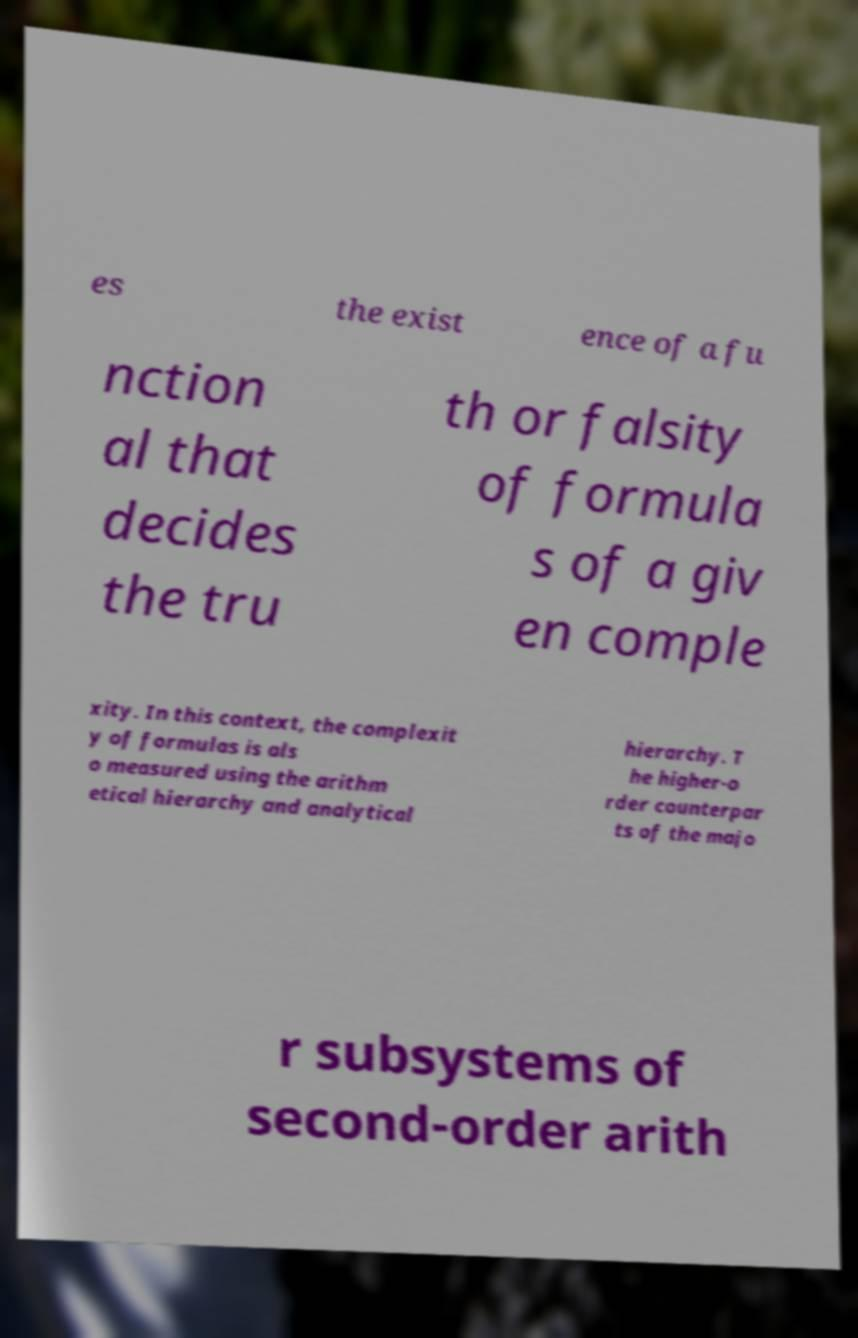Could you assist in decoding the text presented in this image and type it out clearly? es the exist ence of a fu nction al that decides the tru th or falsity of formula s of a giv en comple xity. In this context, the complexit y of formulas is als o measured using the arithm etical hierarchy and analytical hierarchy. T he higher-o rder counterpar ts of the majo r subsystems of second-order arith 